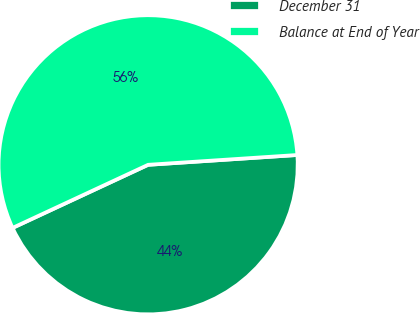Convert chart. <chart><loc_0><loc_0><loc_500><loc_500><pie_chart><fcel>December 31<fcel>Balance at End of Year<nl><fcel>44.11%<fcel>55.89%<nl></chart> 